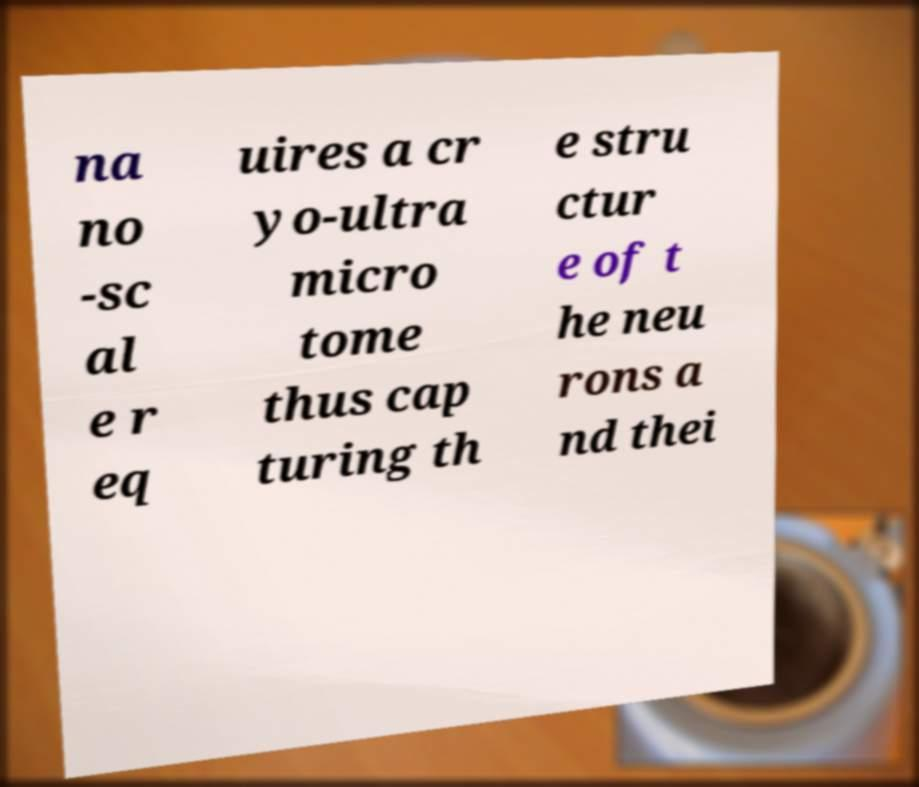Please identify and transcribe the text found in this image. na no -sc al e r eq uires a cr yo-ultra micro tome thus cap turing th e stru ctur e of t he neu rons a nd thei 